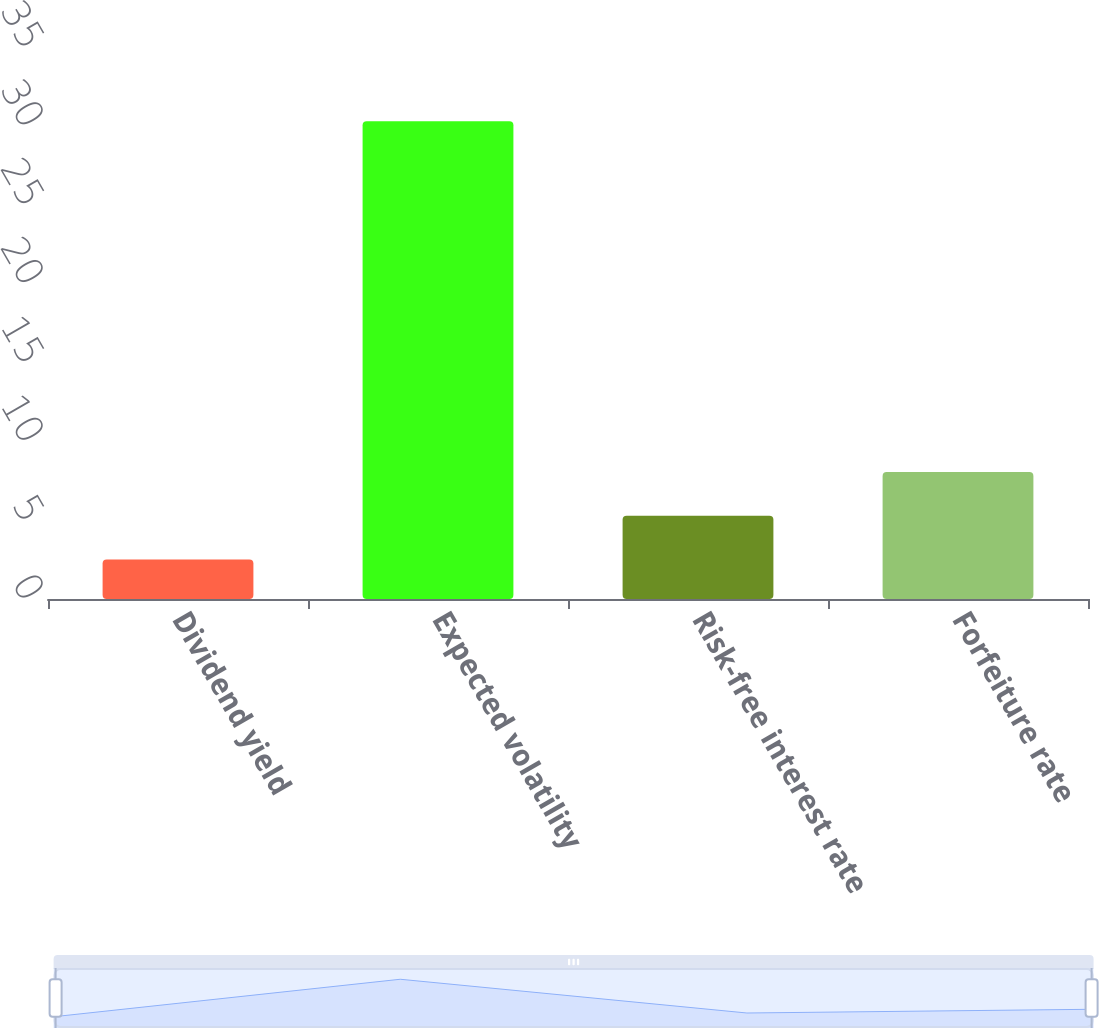<chart> <loc_0><loc_0><loc_500><loc_500><bar_chart><fcel>Dividend yield<fcel>Expected volatility<fcel>Risk-free interest rate<fcel>Forfeiture rate<nl><fcel>2.5<fcel>30.3<fcel>5.28<fcel>8.06<nl></chart> 